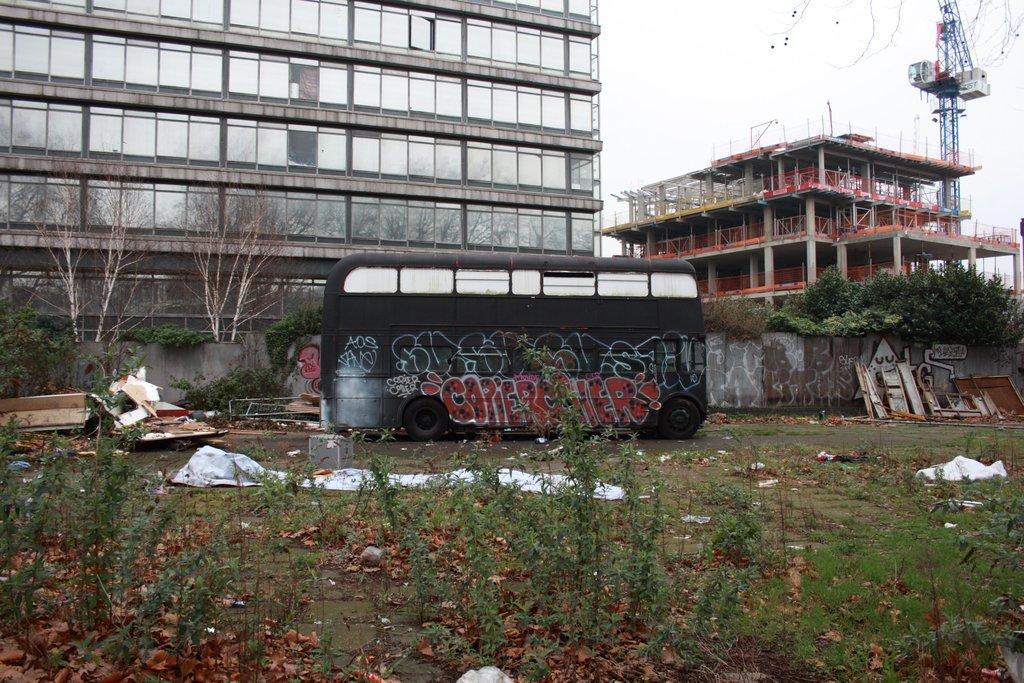Please provide a concise description of this image. In this image, we can see buildings. There is a bus in front of the wall. There are trees on the left and on the right side of the image. There are some plants at the bottom of the image. 